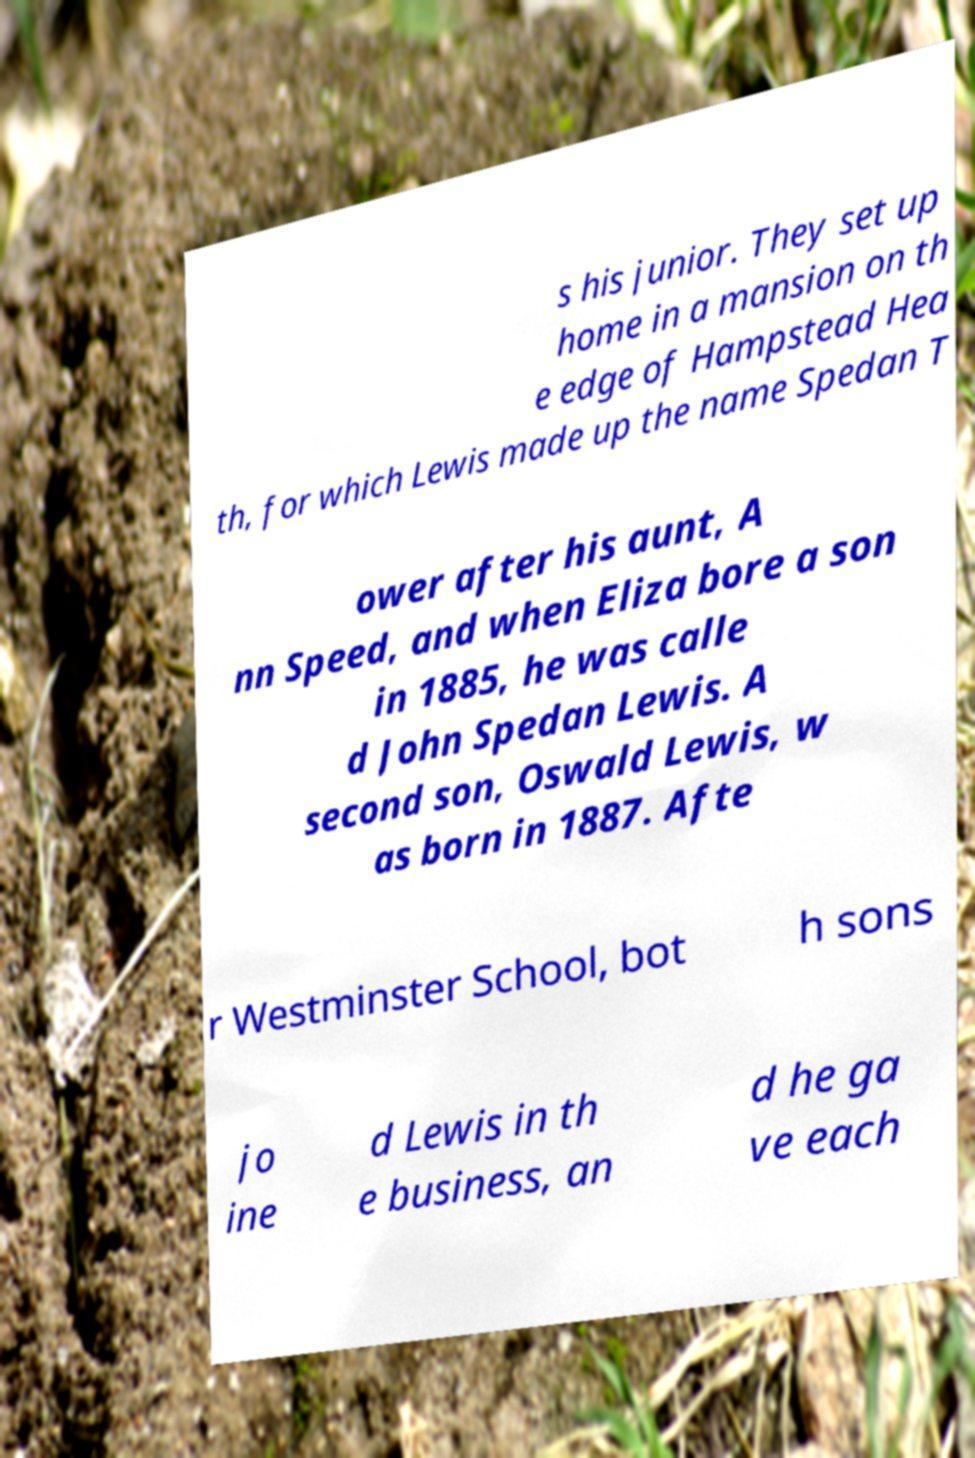I need the written content from this picture converted into text. Can you do that? s his junior. They set up home in a mansion on th e edge of Hampstead Hea th, for which Lewis made up the name Spedan T ower after his aunt, A nn Speed, and when Eliza bore a son in 1885, he was calle d John Spedan Lewis. A second son, Oswald Lewis, w as born in 1887. Afte r Westminster School, bot h sons jo ine d Lewis in th e business, an d he ga ve each 